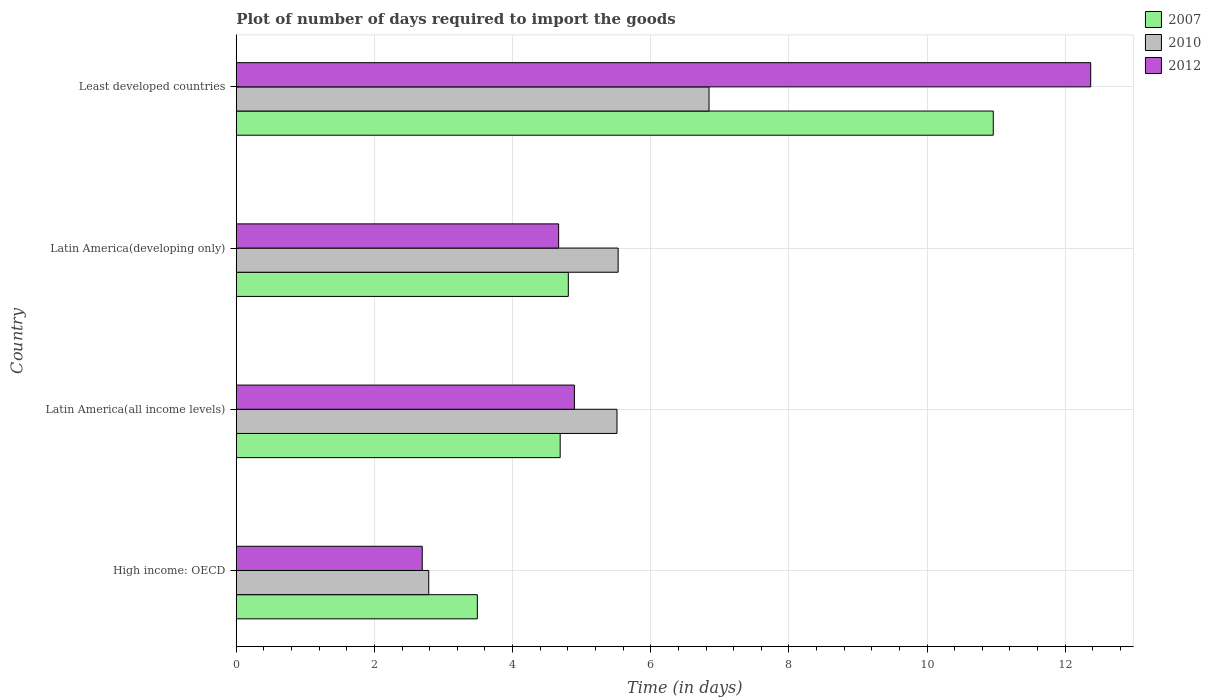Are the number of bars per tick equal to the number of legend labels?
Your answer should be very brief. Yes. How many bars are there on the 2nd tick from the top?
Offer a terse response. 3. What is the label of the 1st group of bars from the top?
Provide a succinct answer. Least developed countries. In how many cases, is the number of bars for a given country not equal to the number of legend labels?
Give a very brief answer. 0. What is the time required to import goods in 2010 in Latin America(all income levels)?
Offer a very short reply. 5.51. Across all countries, what is the maximum time required to import goods in 2010?
Provide a short and direct response. 6.84. Across all countries, what is the minimum time required to import goods in 2010?
Keep it short and to the point. 2.79. In which country was the time required to import goods in 2007 maximum?
Provide a short and direct response. Least developed countries. In which country was the time required to import goods in 2012 minimum?
Your answer should be very brief. High income: OECD. What is the total time required to import goods in 2010 in the graph?
Your answer should be compact. 20.67. What is the difference between the time required to import goods in 2012 in High income: OECD and that in Latin America(all income levels)?
Offer a very short reply. -2.2. What is the difference between the time required to import goods in 2007 in High income: OECD and the time required to import goods in 2010 in Least developed countries?
Your answer should be compact. -3.35. What is the average time required to import goods in 2007 per country?
Give a very brief answer. 5.99. What is the difference between the time required to import goods in 2012 and time required to import goods in 2007 in Latin America(all income levels)?
Your answer should be compact. 0.21. In how many countries, is the time required to import goods in 2007 greater than 4.4 days?
Your answer should be very brief. 3. What is the ratio of the time required to import goods in 2010 in Latin America(developing only) to that in Least developed countries?
Provide a succinct answer. 0.81. Is the time required to import goods in 2007 in Latin America(developing only) less than that in Least developed countries?
Offer a very short reply. Yes. What is the difference between the highest and the second highest time required to import goods in 2012?
Offer a terse response. 7.47. What is the difference between the highest and the lowest time required to import goods in 2012?
Your answer should be very brief. 9.68. Is the sum of the time required to import goods in 2010 in Latin America(developing only) and Least developed countries greater than the maximum time required to import goods in 2012 across all countries?
Your answer should be compact. Yes. Is it the case that in every country, the sum of the time required to import goods in 2012 and time required to import goods in 2007 is greater than the time required to import goods in 2010?
Provide a short and direct response. Yes. How many bars are there?
Provide a succinct answer. 12. How many countries are there in the graph?
Your answer should be very brief. 4. What is the difference between two consecutive major ticks on the X-axis?
Your answer should be compact. 2. Are the values on the major ticks of X-axis written in scientific E-notation?
Keep it short and to the point. No. Where does the legend appear in the graph?
Give a very brief answer. Top right. How many legend labels are there?
Your answer should be compact. 3. What is the title of the graph?
Ensure brevity in your answer.  Plot of number of days required to import the goods. What is the label or title of the X-axis?
Ensure brevity in your answer.  Time (in days). What is the Time (in days) in 2007 in High income: OECD?
Offer a terse response. 3.49. What is the Time (in days) in 2010 in High income: OECD?
Provide a succinct answer. 2.79. What is the Time (in days) in 2012 in High income: OECD?
Your answer should be compact. 2.69. What is the Time (in days) of 2007 in Latin America(all income levels)?
Make the answer very short. 4.69. What is the Time (in days) in 2010 in Latin America(all income levels)?
Your answer should be compact. 5.51. What is the Time (in days) in 2012 in Latin America(all income levels)?
Your answer should be compact. 4.89. What is the Time (in days) in 2007 in Latin America(developing only)?
Provide a short and direct response. 4.81. What is the Time (in days) in 2010 in Latin America(developing only)?
Make the answer very short. 5.53. What is the Time (in days) of 2012 in Latin America(developing only)?
Offer a very short reply. 4.67. What is the Time (in days) in 2007 in Least developed countries?
Offer a terse response. 10.96. What is the Time (in days) in 2010 in Least developed countries?
Provide a succinct answer. 6.84. What is the Time (in days) in 2012 in Least developed countries?
Your answer should be compact. 12.37. Across all countries, what is the maximum Time (in days) in 2007?
Your answer should be very brief. 10.96. Across all countries, what is the maximum Time (in days) of 2010?
Offer a very short reply. 6.84. Across all countries, what is the maximum Time (in days) of 2012?
Make the answer very short. 12.37. Across all countries, what is the minimum Time (in days) of 2007?
Keep it short and to the point. 3.49. Across all countries, what is the minimum Time (in days) in 2010?
Offer a very short reply. 2.79. Across all countries, what is the minimum Time (in days) of 2012?
Your answer should be very brief. 2.69. What is the total Time (in days) in 2007 in the graph?
Your response must be concise. 23.94. What is the total Time (in days) in 2010 in the graph?
Offer a very short reply. 20.67. What is the total Time (in days) in 2012 in the graph?
Offer a very short reply. 24.62. What is the difference between the Time (in days) in 2007 in High income: OECD and that in Latin America(all income levels)?
Your answer should be compact. -1.2. What is the difference between the Time (in days) of 2010 in High income: OECD and that in Latin America(all income levels)?
Your response must be concise. -2.73. What is the difference between the Time (in days) in 2012 in High income: OECD and that in Latin America(all income levels)?
Provide a succinct answer. -2.2. What is the difference between the Time (in days) in 2007 in High income: OECD and that in Latin America(developing only)?
Your answer should be compact. -1.32. What is the difference between the Time (in days) of 2010 in High income: OECD and that in Latin America(developing only)?
Give a very brief answer. -2.74. What is the difference between the Time (in days) in 2012 in High income: OECD and that in Latin America(developing only)?
Your answer should be compact. -1.97. What is the difference between the Time (in days) in 2007 in High income: OECD and that in Least developed countries?
Offer a very short reply. -7.47. What is the difference between the Time (in days) in 2010 in High income: OECD and that in Least developed countries?
Give a very brief answer. -4.06. What is the difference between the Time (in days) in 2012 in High income: OECD and that in Least developed countries?
Provide a short and direct response. -9.68. What is the difference between the Time (in days) in 2007 in Latin America(all income levels) and that in Latin America(developing only)?
Offer a very short reply. -0.12. What is the difference between the Time (in days) in 2010 in Latin America(all income levels) and that in Latin America(developing only)?
Your answer should be compact. -0.02. What is the difference between the Time (in days) in 2012 in Latin America(all income levels) and that in Latin America(developing only)?
Offer a very short reply. 0.23. What is the difference between the Time (in days) in 2007 in Latin America(all income levels) and that in Least developed countries?
Ensure brevity in your answer.  -6.27. What is the difference between the Time (in days) of 2010 in Latin America(all income levels) and that in Least developed countries?
Ensure brevity in your answer.  -1.33. What is the difference between the Time (in days) of 2012 in Latin America(all income levels) and that in Least developed countries?
Your answer should be very brief. -7.47. What is the difference between the Time (in days) in 2007 in Latin America(developing only) and that in Least developed countries?
Keep it short and to the point. -6.15. What is the difference between the Time (in days) in 2010 in Latin America(developing only) and that in Least developed countries?
Your answer should be compact. -1.32. What is the difference between the Time (in days) in 2012 in Latin America(developing only) and that in Least developed countries?
Give a very brief answer. -7.7. What is the difference between the Time (in days) in 2007 in High income: OECD and the Time (in days) in 2010 in Latin America(all income levels)?
Offer a very short reply. -2.02. What is the difference between the Time (in days) of 2007 in High income: OECD and the Time (in days) of 2012 in Latin America(all income levels)?
Your response must be concise. -1.41. What is the difference between the Time (in days) in 2010 in High income: OECD and the Time (in days) in 2012 in Latin America(all income levels)?
Give a very brief answer. -2.11. What is the difference between the Time (in days) in 2007 in High income: OECD and the Time (in days) in 2010 in Latin America(developing only)?
Give a very brief answer. -2.04. What is the difference between the Time (in days) of 2007 in High income: OECD and the Time (in days) of 2012 in Latin America(developing only)?
Your answer should be compact. -1.18. What is the difference between the Time (in days) of 2010 in High income: OECD and the Time (in days) of 2012 in Latin America(developing only)?
Provide a succinct answer. -1.88. What is the difference between the Time (in days) of 2007 in High income: OECD and the Time (in days) of 2010 in Least developed countries?
Give a very brief answer. -3.35. What is the difference between the Time (in days) in 2007 in High income: OECD and the Time (in days) in 2012 in Least developed countries?
Give a very brief answer. -8.88. What is the difference between the Time (in days) of 2010 in High income: OECD and the Time (in days) of 2012 in Least developed countries?
Make the answer very short. -9.58. What is the difference between the Time (in days) in 2007 in Latin America(all income levels) and the Time (in days) in 2010 in Latin America(developing only)?
Offer a very short reply. -0.84. What is the difference between the Time (in days) in 2007 in Latin America(all income levels) and the Time (in days) in 2012 in Latin America(developing only)?
Make the answer very short. 0.02. What is the difference between the Time (in days) of 2010 in Latin America(all income levels) and the Time (in days) of 2012 in Latin America(developing only)?
Ensure brevity in your answer.  0.84. What is the difference between the Time (in days) of 2007 in Latin America(all income levels) and the Time (in days) of 2010 in Least developed countries?
Give a very brief answer. -2.15. What is the difference between the Time (in days) of 2007 in Latin America(all income levels) and the Time (in days) of 2012 in Least developed countries?
Offer a terse response. -7.68. What is the difference between the Time (in days) of 2010 in Latin America(all income levels) and the Time (in days) of 2012 in Least developed countries?
Provide a short and direct response. -6.86. What is the difference between the Time (in days) of 2007 in Latin America(developing only) and the Time (in days) of 2010 in Least developed countries?
Give a very brief answer. -2.04. What is the difference between the Time (in days) of 2007 in Latin America(developing only) and the Time (in days) of 2012 in Least developed countries?
Your answer should be very brief. -7.56. What is the difference between the Time (in days) of 2010 in Latin America(developing only) and the Time (in days) of 2012 in Least developed countries?
Provide a succinct answer. -6.84. What is the average Time (in days) in 2007 per country?
Make the answer very short. 5.99. What is the average Time (in days) in 2010 per country?
Your answer should be compact. 5.17. What is the average Time (in days) of 2012 per country?
Provide a short and direct response. 6.16. What is the difference between the Time (in days) in 2007 and Time (in days) in 2010 in High income: OECD?
Your answer should be compact. 0.7. What is the difference between the Time (in days) in 2007 and Time (in days) in 2012 in High income: OECD?
Keep it short and to the point. 0.8. What is the difference between the Time (in days) of 2010 and Time (in days) of 2012 in High income: OECD?
Your answer should be compact. 0.09. What is the difference between the Time (in days) of 2007 and Time (in days) of 2010 in Latin America(all income levels)?
Offer a very short reply. -0.82. What is the difference between the Time (in days) in 2007 and Time (in days) in 2012 in Latin America(all income levels)?
Provide a succinct answer. -0.21. What is the difference between the Time (in days) of 2010 and Time (in days) of 2012 in Latin America(all income levels)?
Provide a short and direct response. 0.62. What is the difference between the Time (in days) of 2007 and Time (in days) of 2010 in Latin America(developing only)?
Offer a very short reply. -0.72. What is the difference between the Time (in days) in 2007 and Time (in days) in 2012 in Latin America(developing only)?
Your response must be concise. 0.14. What is the difference between the Time (in days) in 2010 and Time (in days) in 2012 in Latin America(developing only)?
Make the answer very short. 0.86. What is the difference between the Time (in days) in 2007 and Time (in days) in 2010 in Least developed countries?
Your answer should be compact. 4.11. What is the difference between the Time (in days) in 2007 and Time (in days) in 2012 in Least developed countries?
Ensure brevity in your answer.  -1.41. What is the difference between the Time (in days) of 2010 and Time (in days) of 2012 in Least developed countries?
Provide a succinct answer. -5.52. What is the ratio of the Time (in days) of 2007 in High income: OECD to that in Latin America(all income levels)?
Ensure brevity in your answer.  0.74. What is the ratio of the Time (in days) of 2010 in High income: OECD to that in Latin America(all income levels)?
Your answer should be compact. 0.51. What is the ratio of the Time (in days) in 2012 in High income: OECD to that in Latin America(all income levels)?
Offer a terse response. 0.55. What is the ratio of the Time (in days) in 2007 in High income: OECD to that in Latin America(developing only)?
Provide a short and direct response. 0.73. What is the ratio of the Time (in days) in 2010 in High income: OECD to that in Latin America(developing only)?
Provide a succinct answer. 0.5. What is the ratio of the Time (in days) of 2012 in High income: OECD to that in Latin America(developing only)?
Your answer should be compact. 0.58. What is the ratio of the Time (in days) in 2007 in High income: OECD to that in Least developed countries?
Provide a short and direct response. 0.32. What is the ratio of the Time (in days) of 2010 in High income: OECD to that in Least developed countries?
Your answer should be compact. 0.41. What is the ratio of the Time (in days) of 2012 in High income: OECD to that in Least developed countries?
Your response must be concise. 0.22. What is the ratio of the Time (in days) in 2007 in Latin America(all income levels) to that in Latin America(developing only)?
Give a very brief answer. 0.98. What is the ratio of the Time (in days) of 2010 in Latin America(all income levels) to that in Latin America(developing only)?
Offer a terse response. 1. What is the ratio of the Time (in days) in 2012 in Latin America(all income levels) to that in Latin America(developing only)?
Offer a terse response. 1.05. What is the ratio of the Time (in days) in 2007 in Latin America(all income levels) to that in Least developed countries?
Keep it short and to the point. 0.43. What is the ratio of the Time (in days) of 2010 in Latin America(all income levels) to that in Least developed countries?
Make the answer very short. 0.81. What is the ratio of the Time (in days) of 2012 in Latin America(all income levels) to that in Least developed countries?
Your response must be concise. 0.4. What is the ratio of the Time (in days) of 2007 in Latin America(developing only) to that in Least developed countries?
Provide a succinct answer. 0.44. What is the ratio of the Time (in days) of 2010 in Latin America(developing only) to that in Least developed countries?
Your answer should be very brief. 0.81. What is the ratio of the Time (in days) in 2012 in Latin America(developing only) to that in Least developed countries?
Offer a very short reply. 0.38. What is the difference between the highest and the second highest Time (in days) in 2007?
Offer a very short reply. 6.15. What is the difference between the highest and the second highest Time (in days) of 2010?
Offer a terse response. 1.32. What is the difference between the highest and the second highest Time (in days) in 2012?
Provide a succinct answer. 7.47. What is the difference between the highest and the lowest Time (in days) in 2007?
Keep it short and to the point. 7.47. What is the difference between the highest and the lowest Time (in days) of 2010?
Provide a succinct answer. 4.06. What is the difference between the highest and the lowest Time (in days) in 2012?
Give a very brief answer. 9.68. 